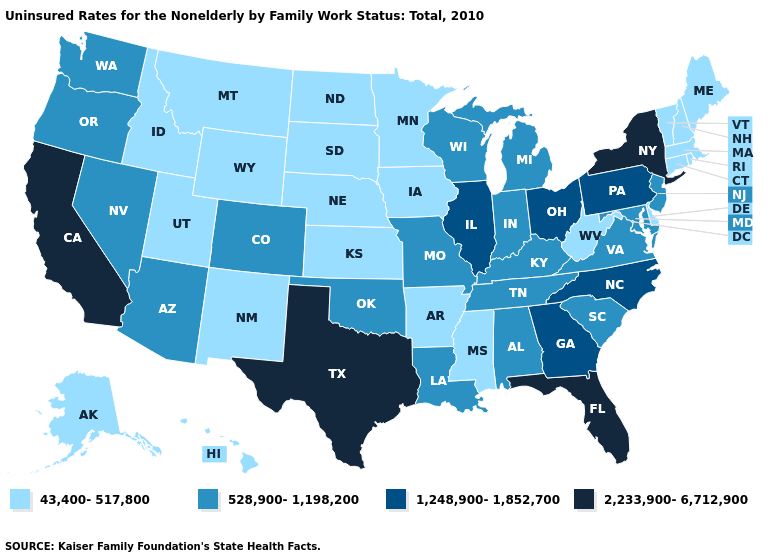Name the states that have a value in the range 1,248,900-1,852,700?
Be succinct. Georgia, Illinois, North Carolina, Ohio, Pennsylvania. Name the states that have a value in the range 43,400-517,800?
Be succinct. Alaska, Arkansas, Connecticut, Delaware, Hawaii, Idaho, Iowa, Kansas, Maine, Massachusetts, Minnesota, Mississippi, Montana, Nebraska, New Hampshire, New Mexico, North Dakota, Rhode Island, South Dakota, Utah, Vermont, West Virginia, Wyoming. How many symbols are there in the legend?
Write a very short answer. 4. Name the states that have a value in the range 528,900-1,198,200?
Quick response, please. Alabama, Arizona, Colorado, Indiana, Kentucky, Louisiana, Maryland, Michigan, Missouri, Nevada, New Jersey, Oklahoma, Oregon, South Carolina, Tennessee, Virginia, Washington, Wisconsin. Name the states that have a value in the range 2,233,900-6,712,900?
Give a very brief answer. California, Florida, New York, Texas. Name the states that have a value in the range 2,233,900-6,712,900?
Quick response, please. California, Florida, New York, Texas. What is the lowest value in the South?
Quick response, please. 43,400-517,800. What is the value of Colorado?
Concise answer only. 528,900-1,198,200. What is the value of Delaware?
Answer briefly. 43,400-517,800. What is the value of Florida?
Concise answer only. 2,233,900-6,712,900. What is the value of Connecticut?
Be succinct. 43,400-517,800. Does California have the lowest value in the West?
Quick response, please. No. Which states have the lowest value in the MidWest?
Keep it brief. Iowa, Kansas, Minnesota, Nebraska, North Dakota, South Dakota. What is the value of West Virginia?
Give a very brief answer. 43,400-517,800. What is the value of Oregon?
Concise answer only. 528,900-1,198,200. 